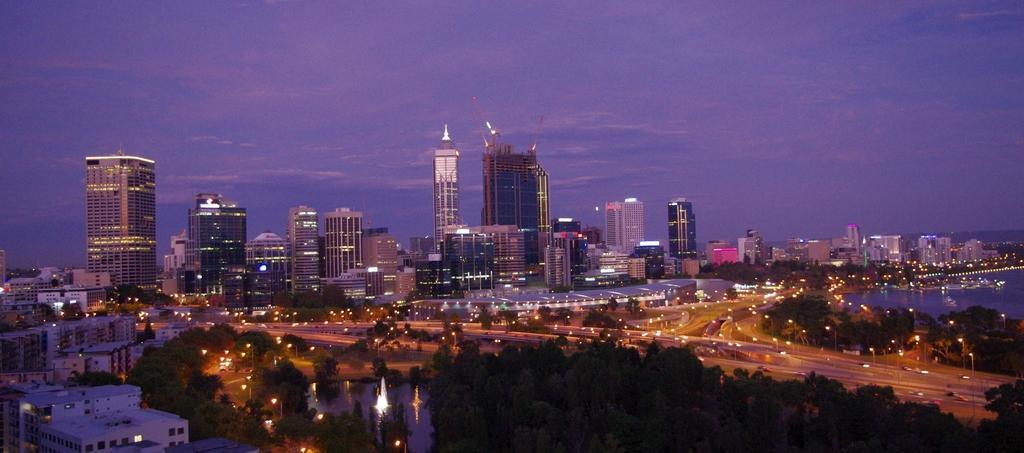Can you describe this image briefly? In this picture we can see buildings, trees, road, water and lights. In the background of the image we can see the sky. 